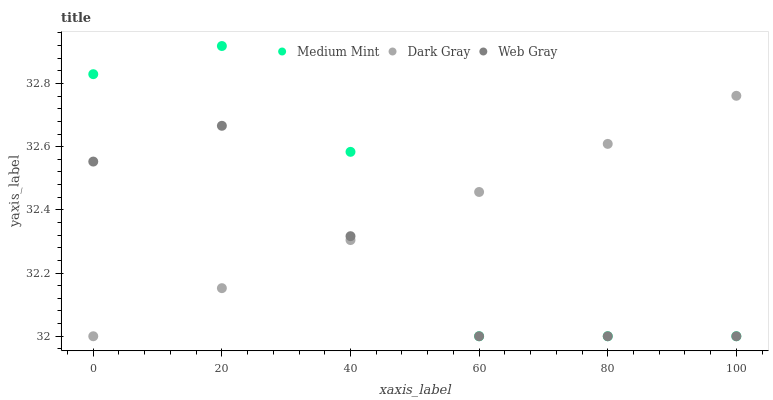Does Web Gray have the minimum area under the curve?
Answer yes or no. Yes. Does Medium Mint have the maximum area under the curve?
Answer yes or no. Yes. Does Dark Gray have the minimum area under the curve?
Answer yes or no. No. Does Dark Gray have the maximum area under the curve?
Answer yes or no. No. Is Dark Gray the smoothest?
Answer yes or no. Yes. Is Medium Mint the roughest?
Answer yes or no. Yes. Is Web Gray the smoothest?
Answer yes or no. No. Is Web Gray the roughest?
Answer yes or no. No. Does Medium Mint have the lowest value?
Answer yes or no. Yes. Does Medium Mint have the highest value?
Answer yes or no. Yes. Does Dark Gray have the highest value?
Answer yes or no. No. Does Medium Mint intersect Web Gray?
Answer yes or no. Yes. Is Medium Mint less than Web Gray?
Answer yes or no. No. Is Medium Mint greater than Web Gray?
Answer yes or no. No. 